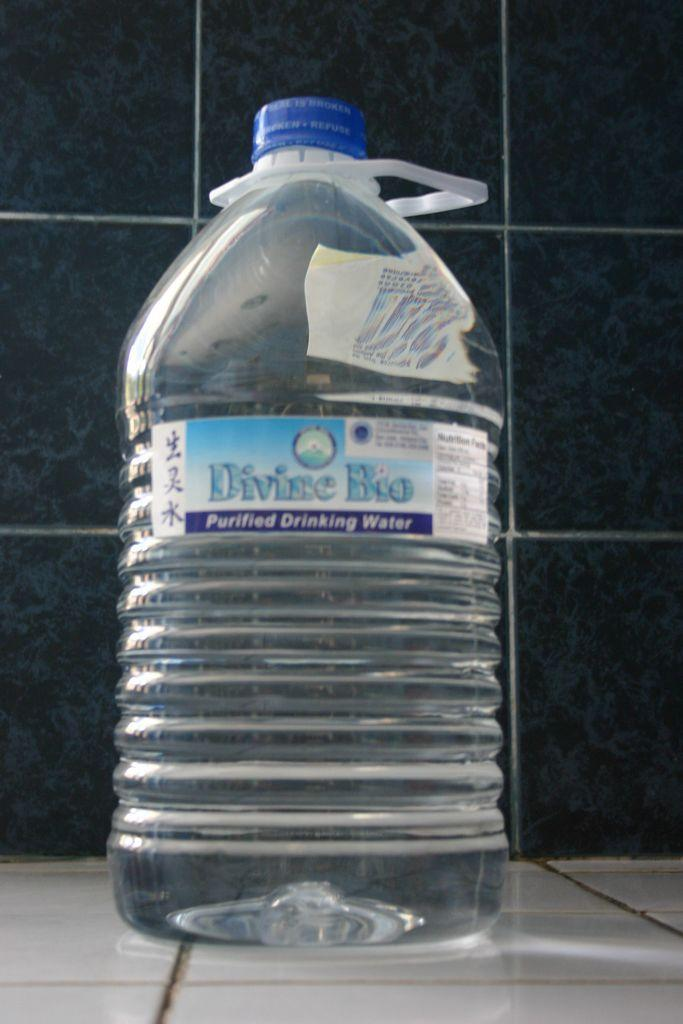<image>
Provide a brief description of the given image. A Divine Bio water bottle has a plastic handle and a blue cap. 